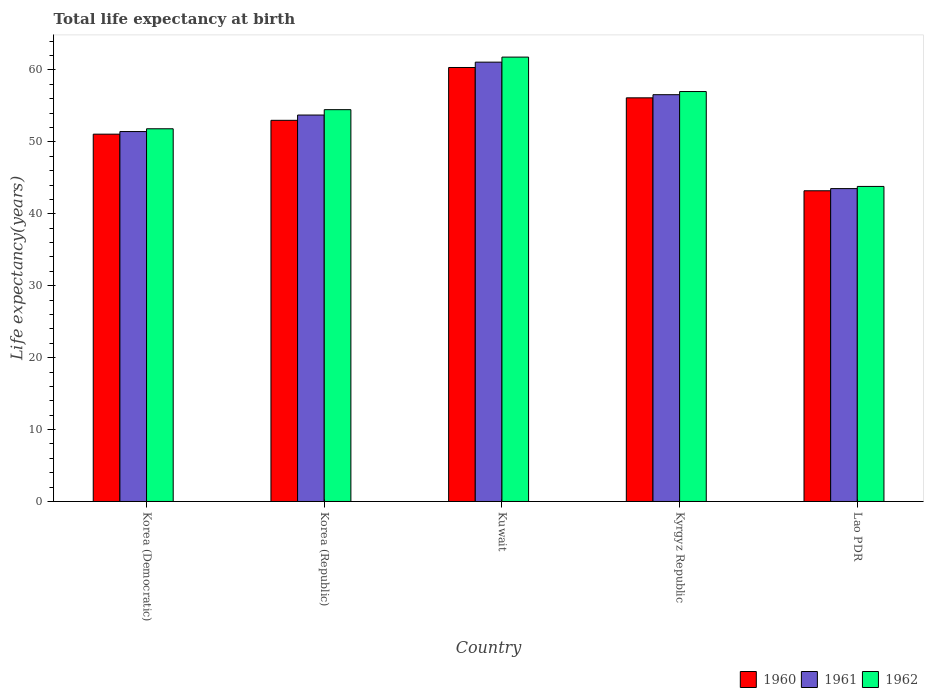How many groups of bars are there?
Provide a short and direct response. 5. Are the number of bars on each tick of the X-axis equal?
Offer a very short reply. Yes. How many bars are there on the 5th tick from the right?
Provide a short and direct response. 3. What is the label of the 5th group of bars from the left?
Offer a terse response. Lao PDR. In how many cases, is the number of bars for a given country not equal to the number of legend labels?
Offer a terse response. 0. What is the life expectancy at birth in in 1961 in Lao PDR?
Make the answer very short. 43.51. Across all countries, what is the maximum life expectancy at birth in in 1960?
Ensure brevity in your answer.  60.35. Across all countries, what is the minimum life expectancy at birth in in 1962?
Your answer should be very brief. 43.81. In which country was the life expectancy at birth in in 1960 maximum?
Make the answer very short. Kuwait. In which country was the life expectancy at birth in in 1960 minimum?
Offer a terse response. Lao PDR. What is the total life expectancy at birth in in 1962 in the graph?
Offer a terse response. 268.91. What is the difference between the life expectancy at birth in in 1960 in Korea (Republic) and that in Lao PDR?
Your answer should be very brief. 9.8. What is the difference between the life expectancy at birth in in 1960 in Kuwait and the life expectancy at birth in in 1961 in Korea (Democratic)?
Make the answer very short. 8.91. What is the average life expectancy at birth in in 1960 per country?
Offer a very short reply. 52.75. What is the difference between the life expectancy at birth in of/in 1960 and life expectancy at birth in of/in 1962 in Korea (Republic)?
Give a very brief answer. -1.48. What is the ratio of the life expectancy at birth in in 1961 in Kuwait to that in Kyrgyz Republic?
Provide a succinct answer. 1.08. What is the difference between the highest and the second highest life expectancy at birth in in 1961?
Your response must be concise. 2.83. What is the difference between the highest and the lowest life expectancy at birth in in 1960?
Offer a very short reply. 17.14. In how many countries, is the life expectancy at birth in in 1961 greater than the average life expectancy at birth in in 1961 taken over all countries?
Your response must be concise. 3. Is the sum of the life expectancy at birth in in 1962 in Kuwait and Kyrgyz Republic greater than the maximum life expectancy at birth in in 1961 across all countries?
Offer a very short reply. Yes. What does the 2nd bar from the right in Lao PDR represents?
Give a very brief answer. 1961. Is it the case that in every country, the sum of the life expectancy at birth in in 1962 and life expectancy at birth in in 1960 is greater than the life expectancy at birth in in 1961?
Ensure brevity in your answer.  Yes. Are all the bars in the graph horizontal?
Provide a succinct answer. No. How many countries are there in the graph?
Provide a short and direct response. 5. Are the values on the major ticks of Y-axis written in scientific E-notation?
Provide a succinct answer. No. Does the graph contain grids?
Ensure brevity in your answer.  No. How many legend labels are there?
Your response must be concise. 3. What is the title of the graph?
Make the answer very short. Total life expectancy at birth. What is the label or title of the Y-axis?
Your response must be concise. Life expectancy(years). What is the Life expectancy(years) of 1960 in Korea (Democratic)?
Provide a succinct answer. 51.08. What is the Life expectancy(years) of 1961 in Korea (Democratic)?
Provide a succinct answer. 51.44. What is the Life expectancy(years) in 1962 in Korea (Democratic)?
Provide a short and direct response. 51.83. What is the Life expectancy(years) of 1960 in Korea (Republic)?
Provide a succinct answer. 53. What is the Life expectancy(years) in 1961 in Korea (Republic)?
Keep it short and to the point. 53.74. What is the Life expectancy(years) in 1962 in Korea (Republic)?
Make the answer very short. 54.48. What is the Life expectancy(years) of 1960 in Kuwait?
Your response must be concise. 60.35. What is the Life expectancy(years) of 1961 in Kuwait?
Your answer should be very brief. 61.09. What is the Life expectancy(years) of 1962 in Kuwait?
Make the answer very short. 61.79. What is the Life expectancy(years) in 1960 in Kyrgyz Republic?
Your answer should be very brief. 56.13. What is the Life expectancy(years) of 1961 in Kyrgyz Republic?
Keep it short and to the point. 56.56. What is the Life expectancy(years) of 1962 in Kyrgyz Republic?
Make the answer very short. 57. What is the Life expectancy(years) of 1960 in Lao PDR?
Offer a terse response. 43.2. What is the Life expectancy(years) in 1961 in Lao PDR?
Provide a succinct answer. 43.51. What is the Life expectancy(years) in 1962 in Lao PDR?
Your response must be concise. 43.81. Across all countries, what is the maximum Life expectancy(years) in 1960?
Your answer should be compact. 60.35. Across all countries, what is the maximum Life expectancy(years) of 1961?
Keep it short and to the point. 61.09. Across all countries, what is the maximum Life expectancy(years) in 1962?
Keep it short and to the point. 61.79. Across all countries, what is the minimum Life expectancy(years) of 1960?
Provide a succinct answer. 43.2. Across all countries, what is the minimum Life expectancy(years) of 1961?
Ensure brevity in your answer.  43.51. Across all countries, what is the minimum Life expectancy(years) of 1962?
Offer a very short reply. 43.81. What is the total Life expectancy(years) in 1960 in the graph?
Ensure brevity in your answer.  263.76. What is the total Life expectancy(years) in 1961 in the graph?
Offer a terse response. 266.34. What is the total Life expectancy(years) in 1962 in the graph?
Make the answer very short. 268.91. What is the difference between the Life expectancy(years) of 1960 in Korea (Democratic) and that in Korea (Republic)?
Offer a very short reply. -1.92. What is the difference between the Life expectancy(years) of 1961 in Korea (Democratic) and that in Korea (Republic)?
Offer a very short reply. -2.3. What is the difference between the Life expectancy(years) in 1962 in Korea (Democratic) and that in Korea (Republic)?
Provide a short and direct response. -2.66. What is the difference between the Life expectancy(years) of 1960 in Korea (Democratic) and that in Kuwait?
Your answer should be very brief. -9.27. What is the difference between the Life expectancy(years) in 1961 in Korea (Democratic) and that in Kuwait?
Ensure brevity in your answer.  -9.65. What is the difference between the Life expectancy(years) in 1962 in Korea (Democratic) and that in Kuwait?
Your response must be concise. -9.97. What is the difference between the Life expectancy(years) in 1960 in Korea (Democratic) and that in Kyrgyz Republic?
Your answer should be very brief. -5.05. What is the difference between the Life expectancy(years) in 1961 in Korea (Democratic) and that in Kyrgyz Republic?
Your answer should be compact. -5.13. What is the difference between the Life expectancy(years) of 1962 in Korea (Democratic) and that in Kyrgyz Republic?
Keep it short and to the point. -5.18. What is the difference between the Life expectancy(years) of 1960 in Korea (Democratic) and that in Lao PDR?
Ensure brevity in your answer.  7.87. What is the difference between the Life expectancy(years) of 1961 in Korea (Democratic) and that in Lao PDR?
Provide a succinct answer. 7.93. What is the difference between the Life expectancy(years) of 1962 in Korea (Democratic) and that in Lao PDR?
Ensure brevity in your answer.  8.02. What is the difference between the Life expectancy(years) of 1960 in Korea (Republic) and that in Kuwait?
Provide a short and direct response. -7.35. What is the difference between the Life expectancy(years) in 1961 in Korea (Republic) and that in Kuwait?
Offer a very short reply. -7.35. What is the difference between the Life expectancy(years) in 1962 in Korea (Republic) and that in Kuwait?
Provide a short and direct response. -7.31. What is the difference between the Life expectancy(years) of 1960 in Korea (Republic) and that in Kyrgyz Republic?
Keep it short and to the point. -3.13. What is the difference between the Life expectancy(years) of 1961 in Korea (Republic) and that in Kyrgyz Republic?
Provide a succinct answer. -2.83. What is the difference between the Life expectancy(years) in 1962 in Korea (Republic) and that in Kyrgyz Republic?
Offer a very short reply. -2.52. What is the difference between the Life expectancy(years) of 1960 in Korea (Republic) and that in Lao PDR?
Your answer should be compact. 9.8. What is the difference between the Life expectancy(years) in 1961 in Korea (Republic) and that in Lao PDR?
Your answer should be compact. 10.23. What is the difference between the Life expectancy(years) of 1962 in Korea (Republic) and that in Lao PDR?
Give a very brief answer. 10.68. What is the difference between the Life expectancy(years) in 1960 in Kuwait and that in Kyrgyz Republic?
Your response must be concise. 4.22. What is the difference between the Life expectancy(years) of 1961 in Kuwait and that in Kyrgyz Republic?
Keep it short and to the point. 4.53. What is the difference between the Life expectancy(years) in 1962 in Kuwait and that in Kyrgyz Republic?
Provide a short and direct response. 4.79. What is the difference between the Life expectancy(years) of 1960 in Kuwait and that in Lao PDR?
Give a very brief answer. 17.14. What is the difference between the Life expectancy(years) in 1961 in Kuwait and that in Lao PDR?
Offer a very short reply. 17.58. What is the difference between the Life expectancy(years) of 1962 in Kuwait and that in Lao PDR?
Provide a succinct answer. 17.98. What is the difference between the Life expectancy(years) in 1960 in Kyrgyz Republic and that in Lao PDR?
Offer a very short reply. 12.92. What is the difference between the Life expectancy(years) in 1961 in Kyrgyz Republic and that in Lao PDR?
Provide a succinct answer. 13.06. What is the difference between the Life expectancy(years) of 1962 in Kyrgyz Republic and that in Lao PDR?
Provide a succinct answer. 13.19. What is the difference between the Life expectancy(years) in 1960 in Korea (Democratic) and the Life expectancy(years) in 1961 in Korea (Republic)?
Your answer should be compact. -2.66. What is the difference between the Life expectancy(years) of 1960 in Korea (Democratic) and the Life expectancy(years) of 1962 in Korea (Republic)?
Offer a terse response. -3.41. What is the difference between the Life expectancy(years) of 1961 in Korea (Democratic) and the Life expectancy(years) of 1962 in Korea (Republic)?
Make the answer very short. -3.05. What is the difference between the Life expectancy(years) in 1960 in Korea (Democratic) and the Life expectancy(years) in 1961 in Kuwait?
Provide a succinct answer. -10.01. What is the difference between the Life expectancy(years) in 1960 in Korea (Democratic) and the Life expectancy(years) in 1962 in Kuwait?
Make the answer very short. -10.72. What is the difference between the Life expectancy(years) in 1961 in Korea (Democratic) and the Life expectancy(years) in 1962 in Kuwait?
Ensure brevity in your answer.  -10.35. What is the difference between the Life expectancy(years) in 1960 in Korea (Democratic) and the Life expectancy(years) in 1961 in Kyrgyz Republic?
Keep it short and to the point. -5.49. What is the difference between the Life expectancy(years) of 1960 in Korea (Democratic) and the Life expectancy(years) of 1962 in Kyrgyz Republic?
Make the answer very short. -5.93. What is the difference between the Life expectancy(years) in 1961 in Korea (Democratic) and the Life expectancy(years) in 1962 in Kyrgyz Republic?
Offer a terse response. -5.56. What is the difference between the Life expectancy(years) of 1960 in Korea (Democratic) and the Life expectancy(years) of 1961 in Lao PDR?
Offer a very short reply. 7.57. What is the difference between the Life expectancy(years) in 1960 in Korea (Democratic) and the Life expectancy(years) in 1962 in Lao PDR?
Make the answer very short. 7.27. What is the difference between the Life expectancy(years) of 1961 in Korea (Democratic) and the Life expectancy(years) of 1962 in Lao PDR?
Your answer should be compact. 7.63. What is the difference between the Life expectancy(years) in 1960 in Korea (Republic) and the Life expectancy(years) in 1961 in Kuwait?
Offer a very short reply. -8.09. What is the difference between the Life expectancy(years) of 1960 in Korea (Republic) and the Life expectancy(years) of 1962 in Kuwait?
Your answer should be very brief. -8.79. What is the difference between the Life expectancy(years) in 1961 in Korea (Republic) and the Life expectancy(years) in 1962 in Kuwait?
Your answer should be compact. -8.06. What is the difference between the Life expectancy(years) of 1960 in Korea (Republic) and the Life expectancy(years) of 1961 in Kyrgyz Republic?
Make the answer very short. -3.56. What is the difference between the Life expectancy(years) of 1960 in Korea (Republic) and the Life expectancy(years) of 1962 in Kyrgyz Republic?
Offer a very short reply. -4. What is the difference between the Life expectancy(years) of 1961 in Korea (Republic) and the Life expectancy(years) of 1962 in Kyrgyz Republic?
Provide a succinct answer. -3.27. What is the difference between the Life expectancy(years) in 1960 in Korea (Republic) and the Life expectancy(years) in 1961 in Lao PDR?
Make the answer very short. 9.49. What is the difference between the Life expectancy(years) of 1960 in Korea (Republic) and the Life expectancy(years) of 1962 in Lao PDR?
Keep it short and to the point. 9.19. What is the difference between the Life expectancy(years) in 1961 in Korea (Republic) and the Life expectancy(years) in 1962 in Lao PDR?
Keep it short and to the point. 9.93. What is the difference between the Life expectancy(years) in 1960 in Kuwait and the Life expectancy(years) in 1961 in Kyrgyz Republic?
Offer a terse response. 3.78. What is the difference between the Life expectancy(years) of 1960 in Kuwait and the Life expectancy(years) of 1962 in Kyrgyz Republic?
Your response must be concise. 3.35. What is the difference between the Life expectancy(years) in 1961 in Kuwait and the Life expectancy(years) in 1962 in Kyrgyz Republic?
Your response must be concise. 4.09. What is the difference between the Life expectancy(years) of 1960 in Kuwait and the Life expectancy(years) of 1961 in Lao PDR?
Ensure brevity in your answer.  16.84. What is the difference between the Life expectancy(years) of 1960 in Kuwait and the Life expectancy(years) of 1962 in Lao PDR?
Provide a short and direct response. 16.54. What is the difference between the Life expectancy(years) in 1961 in Kuwait and the Life expectancy(years) in 1962 in Lao PDR?
Offer a very short reply. 17.28. What is the difference between the Life expectancy(years) in 1960 in Kyrgyz Republic and the Life expectancy(years) in 1961 in Lao PDR?
Ensure brevity in your answer.  12.62. What is the difference between the Life expectancy(years) in 1960 in Kyrgyz Republic and the Life expectancy(years) in 1962 in Lao PDR?
Your answer should be compact. 12.32. What is the difference between the Life expectancy(years) in 1961 in Kyrgyz Republic and the Life expectancy(years) in 1962 in Lao PDR?
Ensure brevity in your answer.  12.76. What is the average Life expectancy(years) of 1960 per country?
Provide a succinct answer. 52.75. What is the average Life expectancy(years) of 1961 per country?
Offer a very short reply. 53.27. What is the average Life expectancy(years) in 1962 per country?
Make the answer very short. 53.78. What is the difference between the Life expectancy(years) of 1960 and Life expectancy(years) of 1961 in Korea (Democratic)?
Make the answer very short. -0.36. What is the difference between the Life expectancy(years) in 1960 and Life expectancy(years) in 1962 in Korea (Democratic)?
Offer a very short reply. -0.75. What is the difference between the Life expectancy(years) in 1961 and Life expectancy(years) in 1962 in Korea (Democratic)?
Provide a short and direct response. -0.39. What is the difference between the Life expectancy(years) of 1960 and Life expectancy(years) of 1961 in Korea (Republic)?
Offer a very short reply. -0.73. What is the difference between the Life expectancy(years) of 1960 and Life expectancy(years) of 1962 in Korea (Republic)?
Give a very brief answer. -1.48. What is the difference between the Life expectancy(years) of 1961 and Life expectancy(years) of 1962 in Korea (Republic)?
Give a very brief answer. -0.75. What is the difference between the Life expectancy(years) in 1960 and Life expectancy(years) in 1961 in Kuwait?
Provide a short and direct response. -0.74. What is the difference between the Life expectancy(years) in 1960 and Life expectancy(years) in 1962 in Kuwait?
Provide a short and direct response. -1.45. What is the difference between the Life expectancy(years) of 1961 and Life expectancy(years) of 1962 in Kuwait?
Your answer should be very brief. -0.7. What is the difference between the Life expectancy(years) in 1960 and Life expectancy(years) in 1961 in Kyrgyz Republic?
Offer a terse response. -0.44. What is the difference between the Life expectancy(years) of 1960 and Life expectancy(years) of 1962 in Kyrgyz Republic?
Your response must be concise. -0.87. What is the difference between the Life expectancy(years) in 1961 and Life expectancy(years) in 1962 in Kyrgyz Republic?
Offer a very short reply. -0.44. What is the difference between the Life expectancy(years) in 1960 and Life expectancy(years) in 1961 in Lao PDR?
Make the answer very short. -0.3. What is the difference between the Life expectancy(years) of 1960 and Life expectancy(years) of 1962 in Lao PDR?
Give a very brief answer. -0.6. What is the difference between the Life expectancy(years) in 1961 and Life expectancy(years) in 1962 in Lao PDR?
Offer a terse response. -0.3. What is the ratio of the Life expectancy(years) in 1960 in Korea (Democratic) to that in Korea (Republic)?
Make the answer very short. 0.96. What is the ratio of the Life expectancy(years) of 1961 in Korea (Democratic) to that in Korea (Republic)?
Your response must be concise. 0.96. What is the ratio of the Life expectancy(years) of 1962 in Korea (Democratic) to that in Korea (Republic)?
Your answer should be very brief. 0.95. What is the ratio of the Life expectancy(years) in 1960 in Korea (Democratic) to that in Kuwait?
Make the answer very short. 0.85. What is the ratio of the Life expectancy(years) in 1961 in Korea (Democratic) to that in Kuwait?
Ensure brevity in your answer.  0.84. What is the ratio of the Life expectancy(years) in 1962 in Korea (Democratic) to that in Kuwait?
Give a very brief answer. 0.84. What is the ratio of the Life expectancy(years) in 1960 in Korea (Democratic) to that in Kyrgyz Republic?
Your answer should be compact. 0.91. What is the ratio of the Life expectancy(years) in 1961 in Korea (Democratic) to that in Kyrgyz Republic?
Your answer should be very brief. 0.91. What is the ratio of the Life expectancy(years) of 1962 in Korea (Democratic) to that in Kyrgyz Republic?
Offer a very short reply. 0.91. What is the ratio of the Life expectancy(years) in 1960 in Korea (Democratic) to that in Lao PDR?
Keep it short and to the point. 1.18. What is the ratio of the Life expectancy(years) in 1961 in Korea (Democratic) to that in Lao PDR?
Give a very brief answer. 1.18. What is the ratio of the Life expectancy(years) of 1962 in Korea (Democratic) to that in Lao PDR?
Provide a short and direct response. 1.18. What is the ratio of the Life expectancy(years) in 1960 in Korea (Republic) to that in Kuwait?
Keep it short and to the point. 0.88. What is the ratio of the Life expectancy(years) of 1961 in Korea (Republic) to that in Kuwait?
Provide a succinct answer. 0.88. What is the ratio of the Life expectancy(years) of 1962 in Korea (Republic) to that in Kuwait?
Ensure brevity in your answer.  0.88. What is the ratio of the Life expectancy(years) of 1960 in Korea (Republic) to that in Kyrgyz Republic?
Your response must be concise. 0.94. What is the ratio of the Life expectancy(years) of 1962 in Korea (Republic) to that in Kyrgyz Republic?
Provide a short and direct response. 0.96. What is the ratio of the Life expectancy(years) in 1960 in Korea (Republic) to that in Lao PDR?
Offer a very short reply. 1.23. What is the ratio of the Life expectancy(years) of 1961 in Korea (Republic) to that in Lao PDR?
Give a very brief answer. 1.24. What is the ratio of the Life expectancy(years) in 1962 in Korea (Republic) to that in Lao PDR?
Keep it short and to the point. 1.24. What is the ratio of the Life expectancy(years) of 1960 in Kuwait to that in Kyrgyz Republic?
Ensure brevity in your answer.  1.08. What is the ratio of the Life expectancy(years) in 1962 in Kuwait to that in Kyrgyz Republic?
Provide a short and direct response. 1.08. What is the ratio of the Life expectancy(years) in 1960 in Kuwait to that in Lao PDR?
Make the answer very short. 1.4. What is the ratio of the Life expectancy(years) in 1961 in Kuwait to that in Lao PDR?
Provide a short and direct response. 1.4. What is the ratio of the Life expectancy(years) of 1962 in Kuwait to that in Lao PDR?
Provide a short and direct response. 1.41. What is the ratio of the Life expectancy(years) of 1960 in Kyrgyz Republic to that in Lao PDR?
Ensure brevity in your answer.  1.3. What is the ratio of the Life expectancy(years) of 1961 in Kyrgyz Republic to that in Lao PDR?
Ensure brevity in your answer.  1.3. What is the ratio of the Life expectancy(years) in 1962 in Kyrgyz Republic to that in Lao PDR?
Your answer should be compact. 1.3. What is the difference between the highest and the second highest Life expectancy(years) of 1960?
Provide a short and direct response. 4.22. What is the difference between the highest and the second highest Life expectancy(years) in 1961?
Ensure brevity in your answer.  4.53. What is the difference between the highest and the second highest Life expectancy(years) in 1962?
Ensure brevity in your answer.  4.79. What is the difference between the highest and the lowest Life expectancy(years) in 1960?
Keep it short and to the point. 17.14. What is the difference between the highest and the lowest Life expectancy(years) of 1961?
Give a very brief answer. 17.58. What is the difference between the highest and the lowest Life expectancy(years) in 1962?
Make the answer very short. 17.98. 